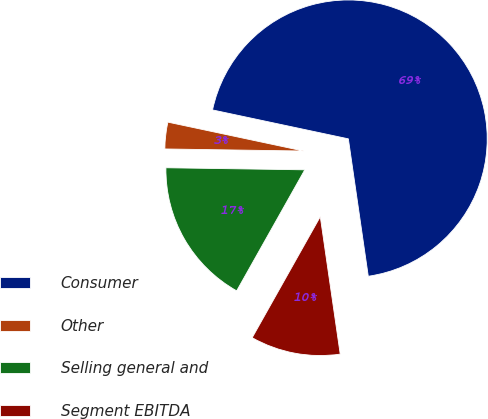Convert chart. <chart><loc_0><loc_0><loc_500><loc_500><pie_chart><fcel>Consumer<fcel>Other<fcel>Selling general and<fcel>Segment EBITDA<nl><fcel>69.37%<fcel>3.1%<fcel>17.08%<fcel>10.45%<nl></chart> 